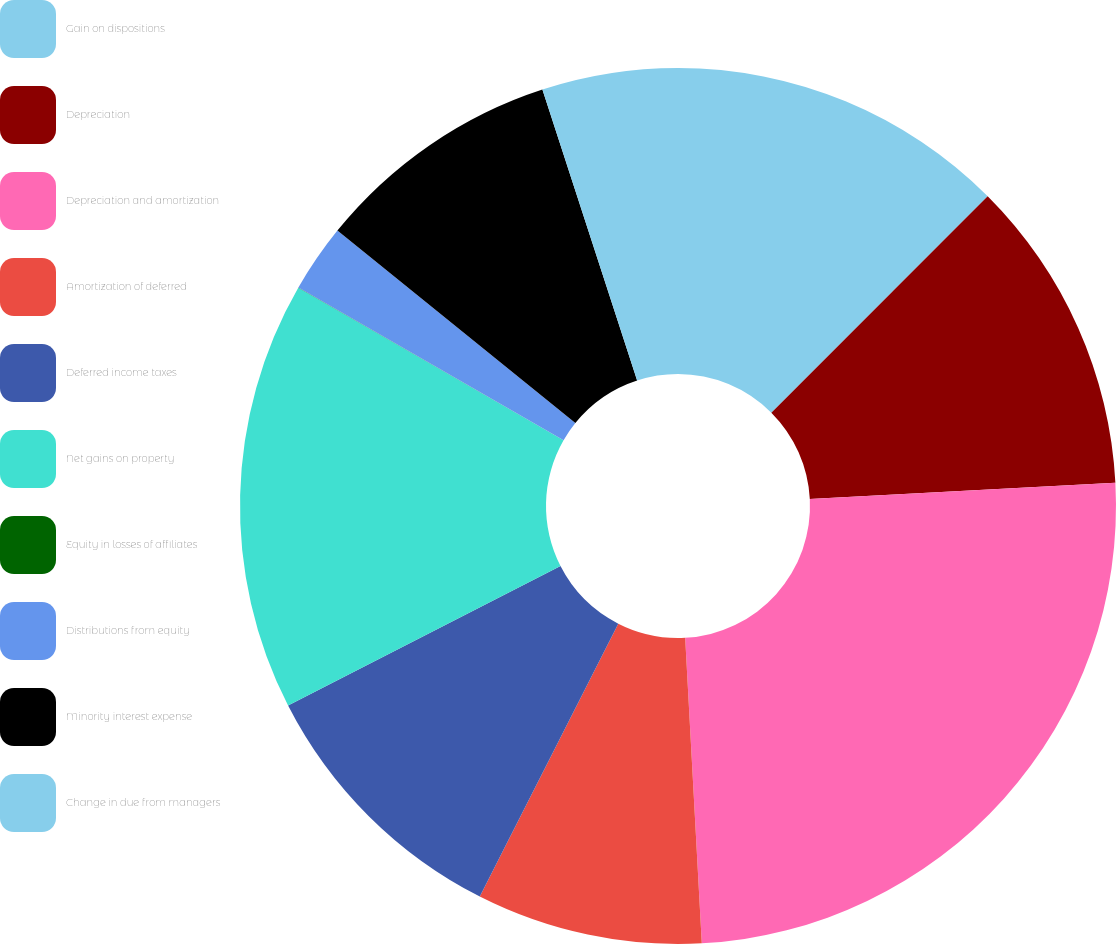Convert chart. <chart><loc_0><loc_0><loc_500><loc_500><pie_chart><fcel>Gain on dispositions<fcel>Depreciation<fcel>Depreciation and amortization<fcel>Amortization of deferred<fcel>Deferred income taxes<fcel>Net gains on property<fcel>Equity in losses of affiliates<fcel>Distributions from equity<fcel>Minority interest expense<fcel>Change in due from managers<nl><fcel>12.5%<fcel>11.66%<fcel>24.98%<fcel>8.34%<fcel>10.0%<fcel>15.83%<fcel>0.01%<fcel>2.51%<fcel>9.17%<fcel>5.01%<nl></chart> 